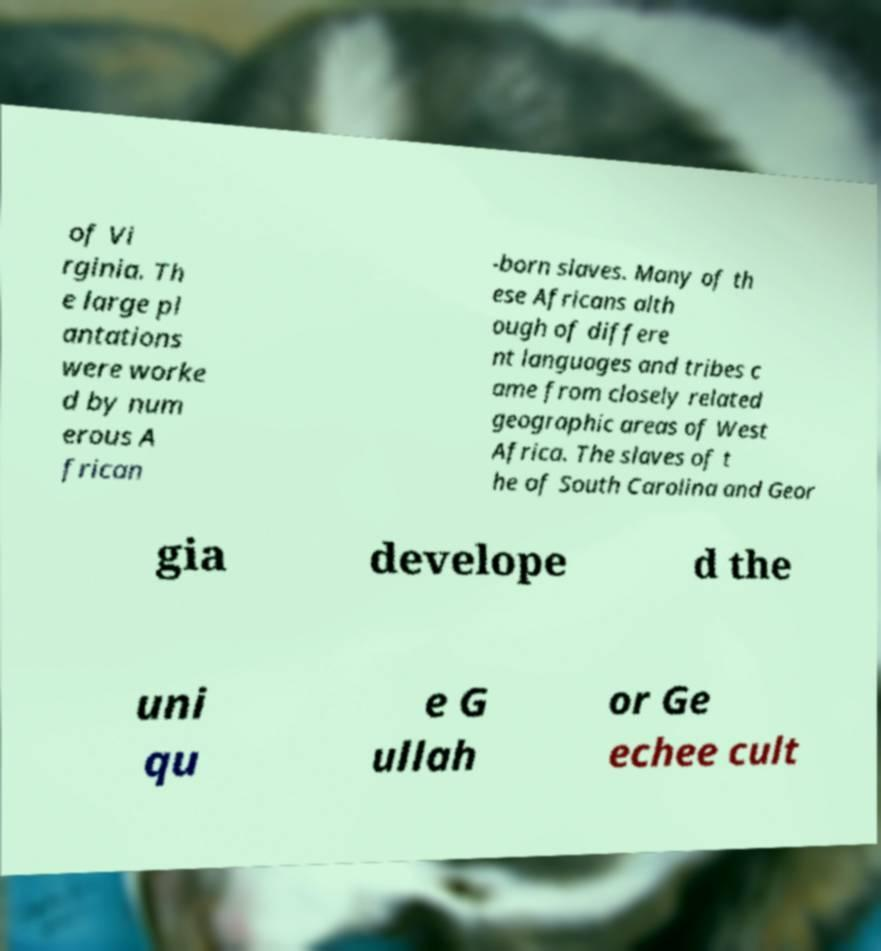I need the written content from this picture converted into text. Can you do that? of Vi rginia. Th e large pl antations were worke d by num erous A frican -born slaves. Many of th ese Africans alth ough of differe nt languages and tribes c ame from closely related geographic areas of West Africa. The slaves of t he of South Carolina and Geor gia develope d the uni qu e G ullah or Ge echee cult 